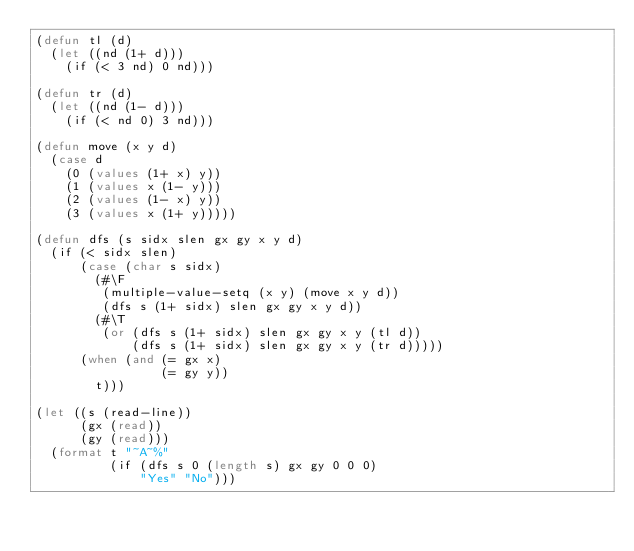Convert code to text. <code><loc_0><loc_0><loc_500><loc_500><_Lisp_>(defun tl (d)
  (let ((nd (1+ d)))
    (if (< 3 nd) 0 nd)))

(defun tr (d)
  (let ((nd (1- d)))
    (if (< nd 0) 3 nd)))

(defun move (x y d)
  (case d
    (0 (values (1+ x) y))
    (1 (values x (1- y)))
    (2 (values (1- x) y))
    (3 (values x (1+ y)))))

(defun dfs (s sidx slen gx gy x y d)
  (if (< sidx slen)
      (case (char s sidx)
        (#\F
         (multiple-value-setq (x y) (move x y d))
         (dfs s (1+ sidx) slen gx gy x y d))
        (#\T
         (or (dfs s (1+ sidx) slen gx gy x y (tl d))
             (dfs s (1+ sidx) slen gx gy x y (tr d)))))
      (when (and (= gx x)
                 (= gy y))
        t)))

(let ((s (read-line))
      (gx (read))
      (gy (read)))
  (format t "~A~%"
          (if (dfs s 0 (length s) gx gy 0 0 0)
              "Yes" "No")))</code> 